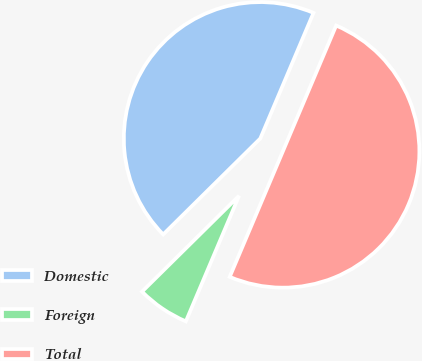Convert chart. <chart><loc_0><loc_0><loc_500><loc_500><pie_chart><fcel>Domestic<fcel>Foreign<fcel>Total<nl><fcel>43.78%<fcel>6.22%<fcel>50.0%<nl></chart> 